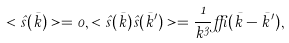Convert formula to latex. <formula><loc_0><loc_0><loc_500><loc_500>< \hat { s } ( \bar { k } ) > = 0 , < \hat { s } ( \bar { k } ) \hat { s } ( \bar { k } ^ { \prime } ) > = \frac { 1 } { k ^ { 3 } } \delta ( \bar { k } - \bar { k } ^ { \prime } ) ,</formula> 